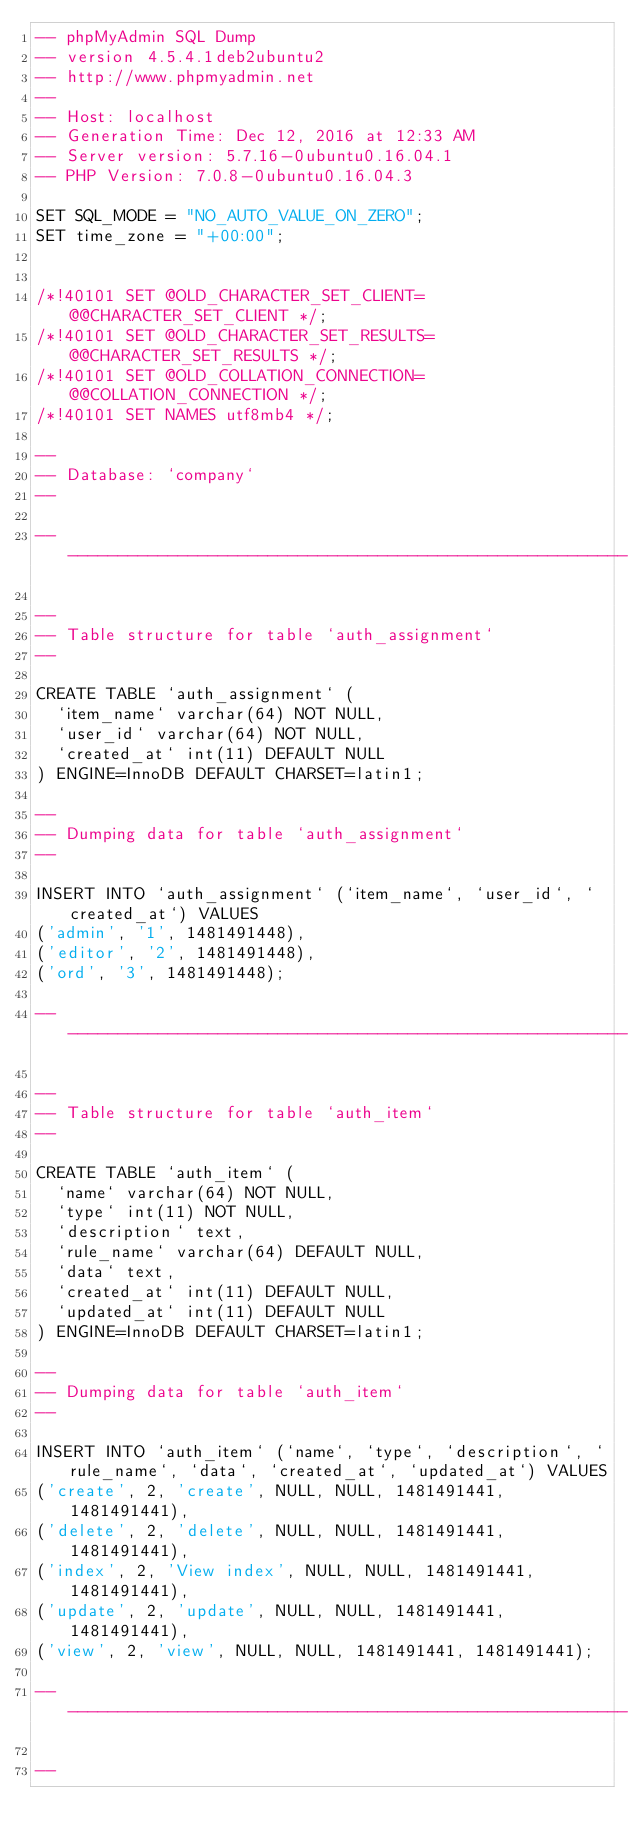Convert code to text. <code><loc_0><loc_0><loc_500><loc_500><_SQL_>-- phpMyAdmin SQL Dump
-- version 4.5.4.1deb2ubuntu2
-- http://www.phpmyadmin.net
--
-- Host: localhost
-- Generation Time: Dec 12, 2016 at 12:33 AM
-- Server version: 5.7.16-0ubuntu0.16.04.1
-- PHP Version: 7.0.8-0ubuntu0.16.04.3

SET SQL_MODE = "NO_AUTO_VALUE_ON_ZERO";
SET time_zone = "+00:00";


/*!40101 SET @OLD_CHARACTER_SET_CLIENT=@@CHARACTER_SET_CLIENT */;
/*!40101 SET @OLD_CHARACTER_SET_RESULTS=@@CHARACTER_SET_RESULTS */;
/*!40101 SET @OLD_COLLATION_CONNECTION=@@COLLATION_CONNECTION */;
/*!40101 SET NAMES utf8mb4 */;

--
-- Database: `company`
--

-- --------------------------------------------------------

--
-- Table structure for table `auth_assignment`
--

CREATE TABLE `auth_assignment` (
  `item_name` varchar(64) NOT NULL,
  `user_id` varchar(64) NOT NULL,
  `created_at` int(11) DEFAULT NULL
) ENGINE=InnoDB DEFAULT CHARSET=latin1;

--
-- Dumping data for table `auth_assignment`
--

INSERT INTO `auth_assignment` (`item_name`, `user_id`, `created_at`) VALUES
('admin', '1', 1481491448),
('editor', '2', 1481491448),
('ord', '3', 1481491448);

-- --------------------------------------------------------

--
-- Table structure for table `auth_item`
--

CREATE TABLE `auth_item` (
  `name` varchar(64) NOT NULL,
  `type` int(11) NOT NULL,
  `description` text,
  `rule_name` varchar(64) DEFAULT NULL,
  `data` text,
  `created_at` int(11) DEFAULT NULL,
  `updated_at` int(11) DEFAULT NULL
) ENGINE=InnoDB DEFAULT CHARSET=latin1;

--
-- Dumping data for table `auth_item`
--

INSERT INTO `auth_item` (`name`, `type`, `description`, `rule_name`, `data`, `created_at`, `updated_at`) VALUES
('create', 2, 'create', NULL, NULL, 1481491441, 1481491441),
('delete', 2, 'delete', NULL, NULL, 1481491441, 1481491441),
('index', 2, 'View index', NULL, NULL, 1481491441, 1481491441),
('update', 2, 'update', NULL, NULL, 1481491441, 1481491441),
('view', 2, 'view', NULL, NULL, 1481491441, 1481491441);

-- --------------------------------------------------------

--</code> 